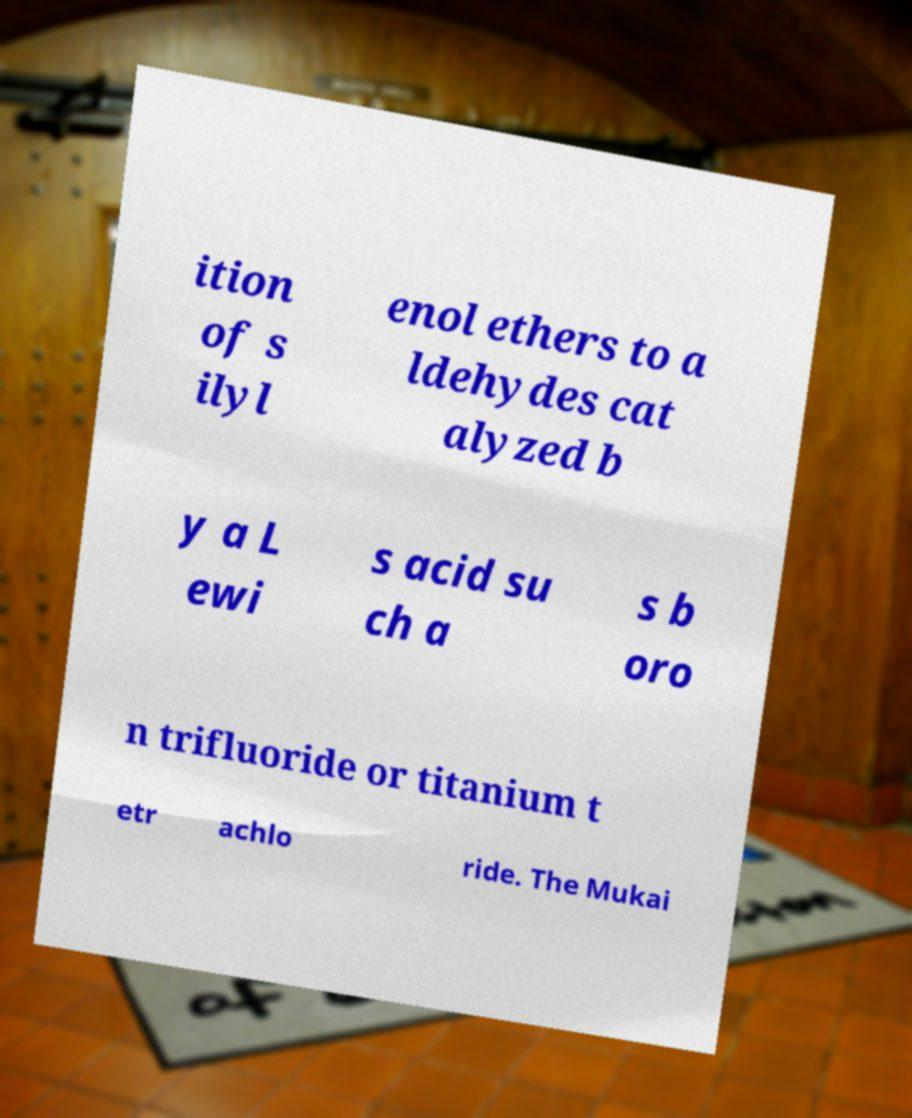There's text embedded in this image that I need extracted. Can you transcribe it verbatim? ition of s ilyl enol ethers to a ldehydes cat alyzed b y a L ewi s acid su ch a s b oro n trifluoride or titanium t etr achlo ride. The Mukai 